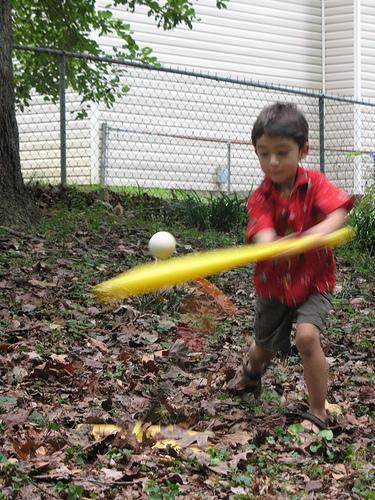How many people are in the photo?
Give a very brief answer. 1. 